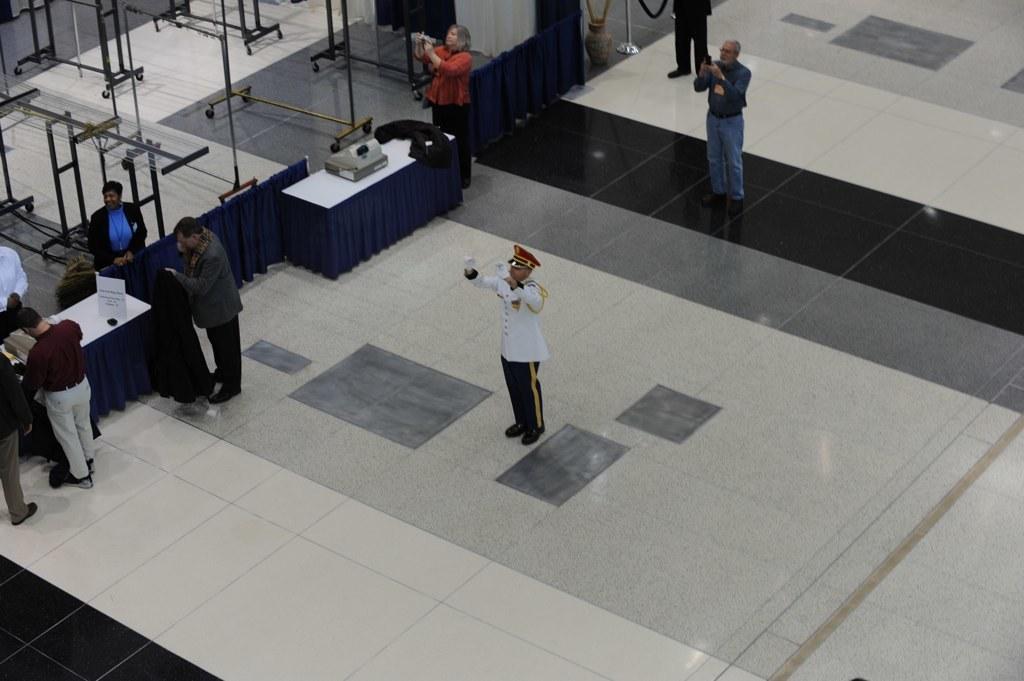Could you give a brief overview of what you see in this image? Here in this picture in the middle we can see a person standing on the floor and we can see he is wearing a uniform with a cap on him over there and we can also see other people standing over there and the persons behind him are capturing something in the cameras present in their hands and we can also see a couple of table with something present on it over there and on the left side we can see some people standing near the table over there and behind them we can see glass tables present on the stands over there. 